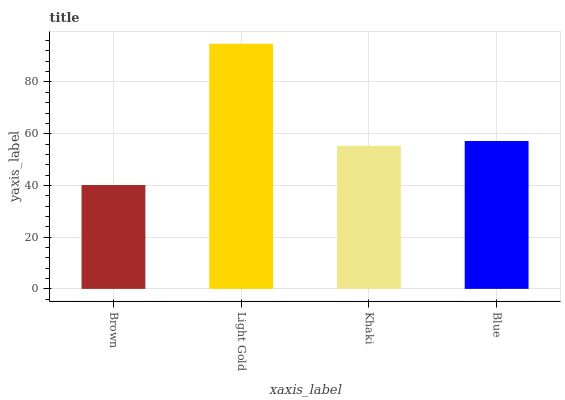Is Brown the minimum?
Answer yes or no. Yes. Is Light Gold the maximum?
Answer yes or no. Yes. Is Khaki the minimum?
Answer yes or no. No. Is Khaki the maximum?
Answer yes or no. No. Is Light Gold greater than Khaki?
Answer yes or no. Yes. Is Khaki less than Light Gold?
Answer yes or no. Yes. Is Khaki greater than Light Gold?
Answer yes or no. No. Is Light Gold less than Khaki?
Answer yes or no. No. Is Blue the high median?
Answer yes or no. Yes. Is Khaki the low median?
Answer yes or no. Yes. Is Light Gold the high median?
Answer yes or no. No. Is Brown the low median?
Answer yes or no. No. 